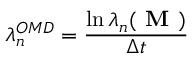Convert formula to latex. <formula><loc_0><loc_0><loc_500><loc_500>\lambda _ { n } ^ { O M D } = \frac { \ln \lambda _ { n } ( M ) } { \Delta t }</formula> 